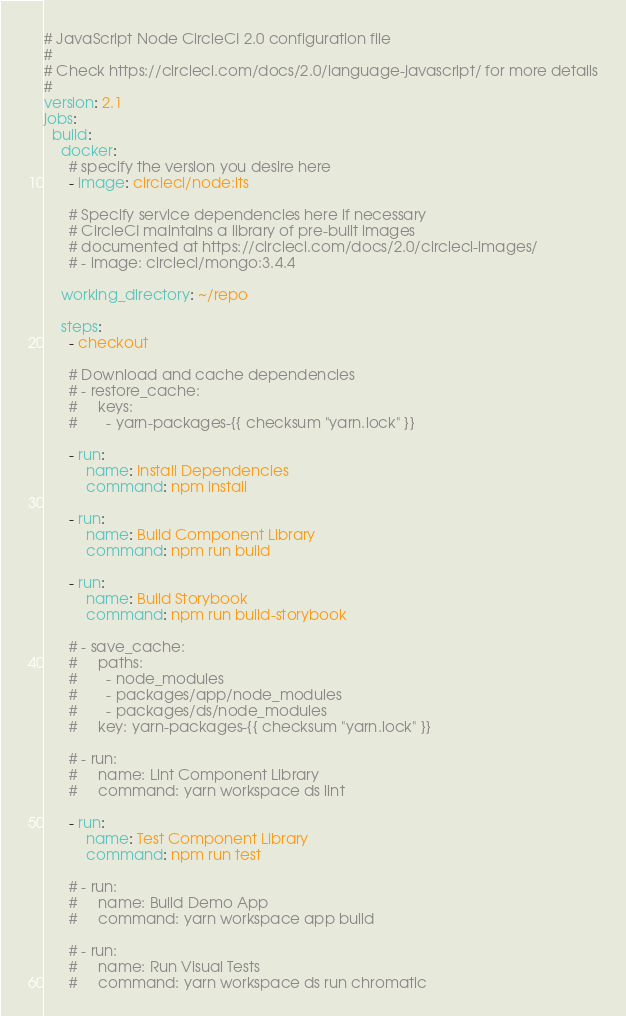Convert code to text. <code><loc_0><loc_0><loc_500><loc_500><_YAML_># JavaScript Node CircleCI 2.0 configuration file
#
# Check https://circleci.com/docs/2.0/language-javascript/ for more details
#
version: 2.1
jobs:
  build:
    docker:
      # specify the version you desire here
      - image: circleci/node:lts

      # Specify service dependencies here if necessary
      # CircleCI maintains a library of pre-built images
      # documented at https://circleci.com/docs/2.0/circleci-images/
      # - image: circleci/mongo:3.4.4

    working_directory: ~/repo

    steps:
      - checkout

      # Download and cache dependencies
      # - restore_cache:
      #     keys:
      #       - yarn-packages-{{ checksum "yarn.lock" }}

      - run:
          name: Install Dependencies
          command: npm install

      - run:
          name: Build Component Library
          command: npm run build

      - run:
          name: Build Storybook
          command: npm run build-storybook

      # - save_cache:
      #     paths:
      #       - node_modules
      #       - packages/app/node_modules
      #       - packages/ds/node_modules
      #     key: yarn-packages-{{ checksum "yarn.lock" }}

      # - run:
      #     name: Lint Component Library
      #     command: yarn workspace ds lint

      - run:
          name: Test Component Library
          command: npm run test

      # - run:
      #     name: Build Demo App
      #     command: yarn workspace app build

      # - run:
      #     name: Run Visual Tests
      #     command: yarn workspace ds run chromatic
</code> 